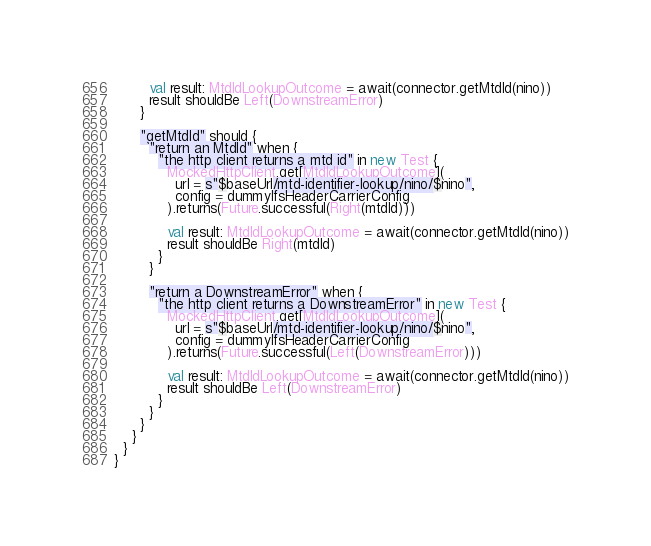Convert code to text. <code><loc_0><loc_0><loc_500><loc_500><_Scala_>        val result: MtdIdLookupOutcome = await(connector.getMtdId(nino))
        result shouldBe Left(DownstreamError)
      }

      "getMtdId" should {
        "return an MtdId" when {
          "the http client returns a mtd id" in new Test {
            MockedHttpClient.get[MtdIdLookupOutcome](
              url = s"$baseUrl/mtd-identifier-lookup/nino/$nino",
              config = dummyIfsHeaderCarrierConfig
            ).returns(Future.successful(Right(mtdId)))

            val result: MtdIdLookupOutcome = await(connector.getMtdId(nino))
            result shouldBe Right(mtdId)
          }
        }

        "return a DownstreamError" when {
          "the http client returns a DownstreamError" in new Test {
            MockedHttpClient.get[MtdIdLookupOutcome](
              url = s"$baseUrl/mtd-identifier-lookup/nino/$nino",
              config = dummyIfsHeaderCarrierConfig
            ).returns(Future.successful(Left(DownstreamError)))

            val result: MtdIdLookupOutcome = await(connector.getMtdId(nino))
            result shouldBe Left(DownstreamError)
          }
        }
      }
    }
  }
}
</code> 